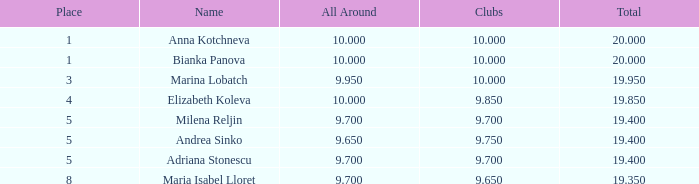What are the lowest clubs that have a place greater than 5, with an all around greater than 9.7? None. 